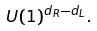<formula> <loc_0><loc_0><loc_500><loc_500>U ( 1 ) ^ { d _ { R } - d _ { L } } .</formula> 